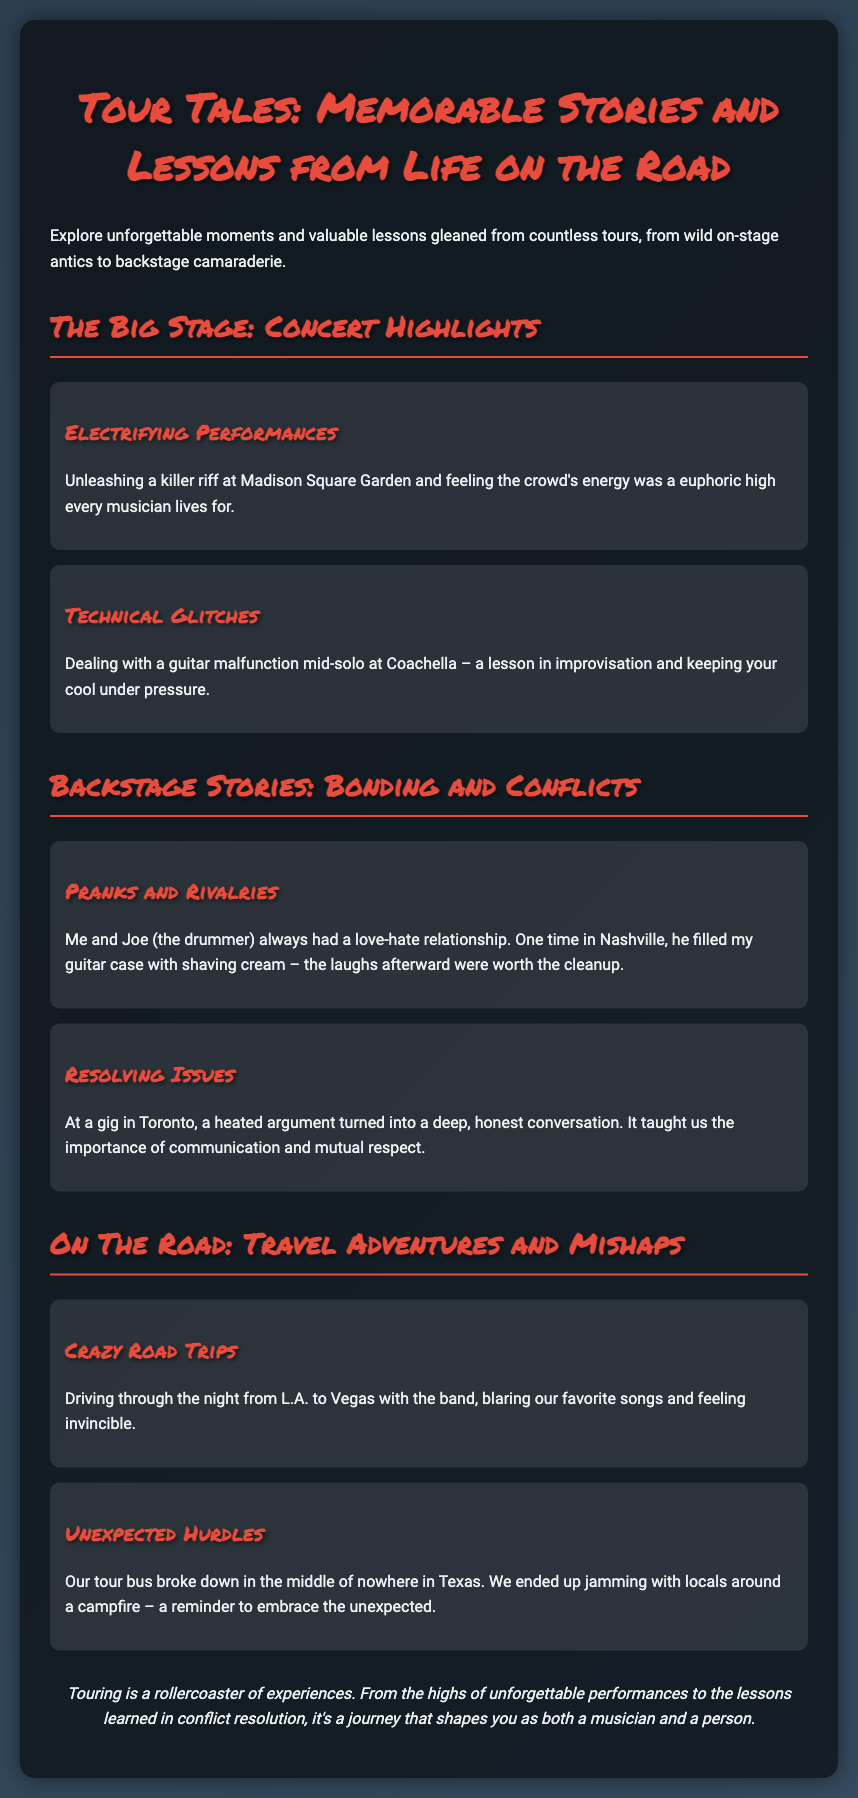What is the title of the presentation? The title of the presentation is "Tour Tales: Memorable Stories and Lessons from Life on the Road."
Answer: Tour Tales: Memorable Stories and Lessons from Life on the Road What is one example of a concert highlight mentioned? The document provides examples of concert highlights, one of which is "Electrifying Performances."
Answer: Electrifying Performances Who did the guitarist have a love-hate relationship with? The document mentions Joe as the drummer with whom the guitarist had a love-hate relationship.
Answer: Joe What important lesson was learned from the argument in Toronto? The document notes that the argument in Toronto taught the importance of communication and mutual respect.
Answer: Communication and mutual respect What unexpected event occurred during the tour in Texas? An unexpected hurdle during the tour was the tour bus breaking down in Texas.
Answer: Tour bus broke down What was the atmosphere during the road trip from L.A. to Vegas? The document describes the atmosphere during the road trip as feeling invincible.
Answer: Feeling invincible What are the two main sections of the presentation? The two main sections are "The Big Stage: Concert Highlights" and "Backstage Stories: Bonding and Conflicts."
Answer: The Big Stage: Concert Highlights, Backstage Stories: Bonding and Conflicts How did the guitarist feel about the crowd at Madison Square Garden? The document expresses that the guitarist felt euphoric about the crowd's energy at Madison Square Garden.
Answer: Euphoric 